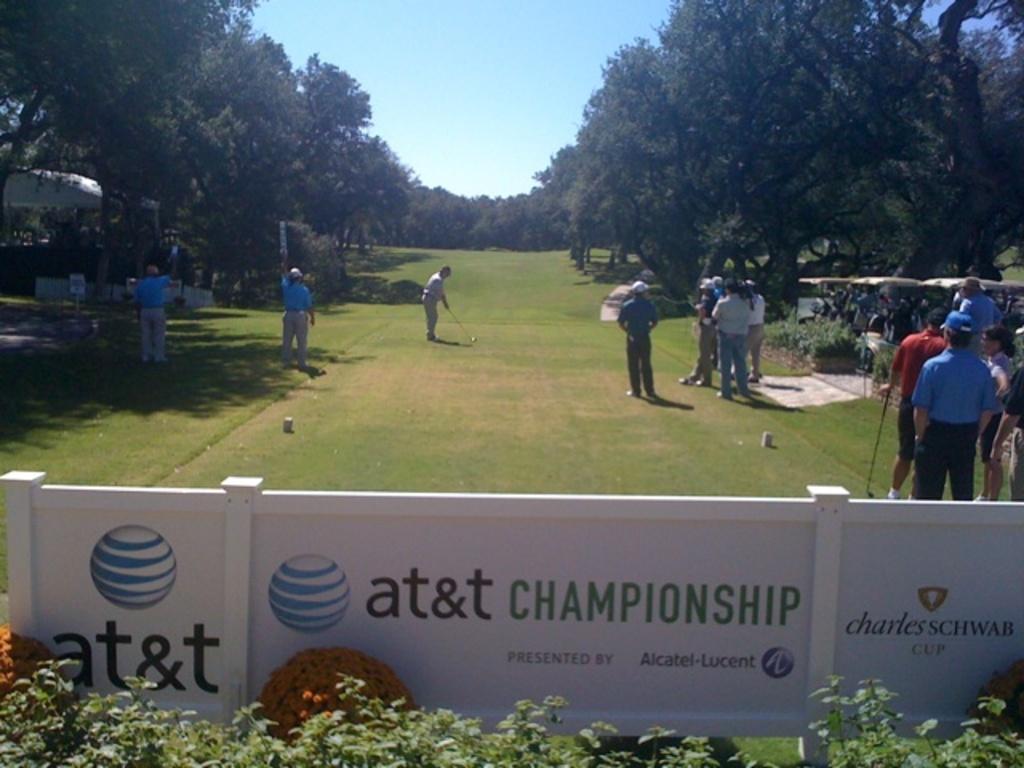Please provide a concise description of this image. In this image in the center there are group of people who are playing hockey, and some of them are holding sticks. At the bottom of the image there are some plants and boards, on the boards there is text. And on the right side and left side of the image there are some trees and plants and some tents. At the top there is sky, and in the center of the image there is ground. 